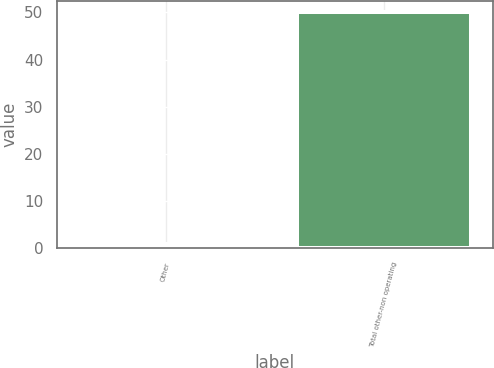Convert chart. <chart><loc_0><loc_0><loc_500><loc_500><bar_chart><fcel>Other<fcel>Total other-non operating<nl><fcel>1<fcel>50<nl></chart> 